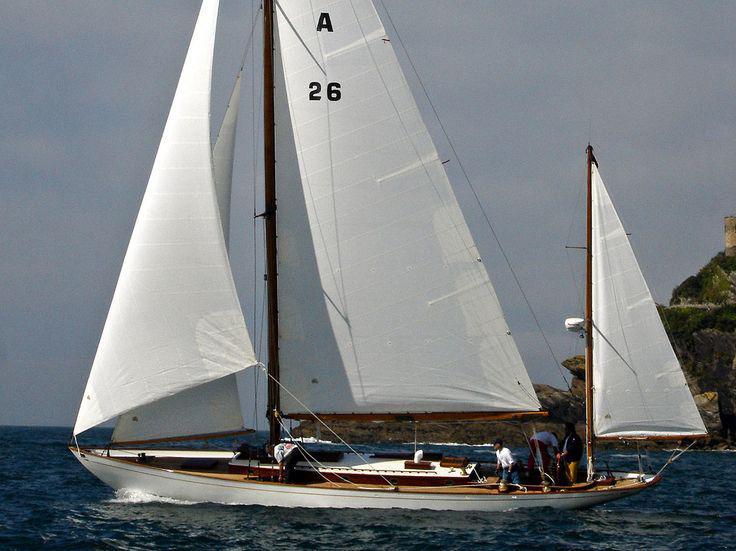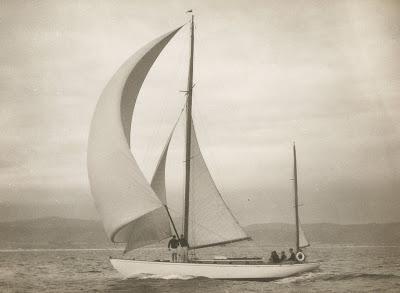The first image is the image on the left, the second image is the image on the right. Evaluate the accuracy of this statement regarding the images: "In the image to the left, the boat has more than four sails unfurled.". Is it true? Answer yes or no. No. 